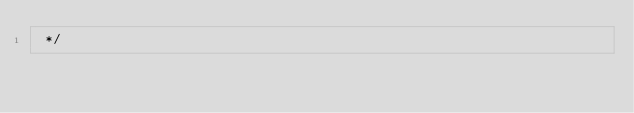Convert code to text. <code><loc_0><loc_0><loc_500><loc_500><_JavaScript_> */
</code> 